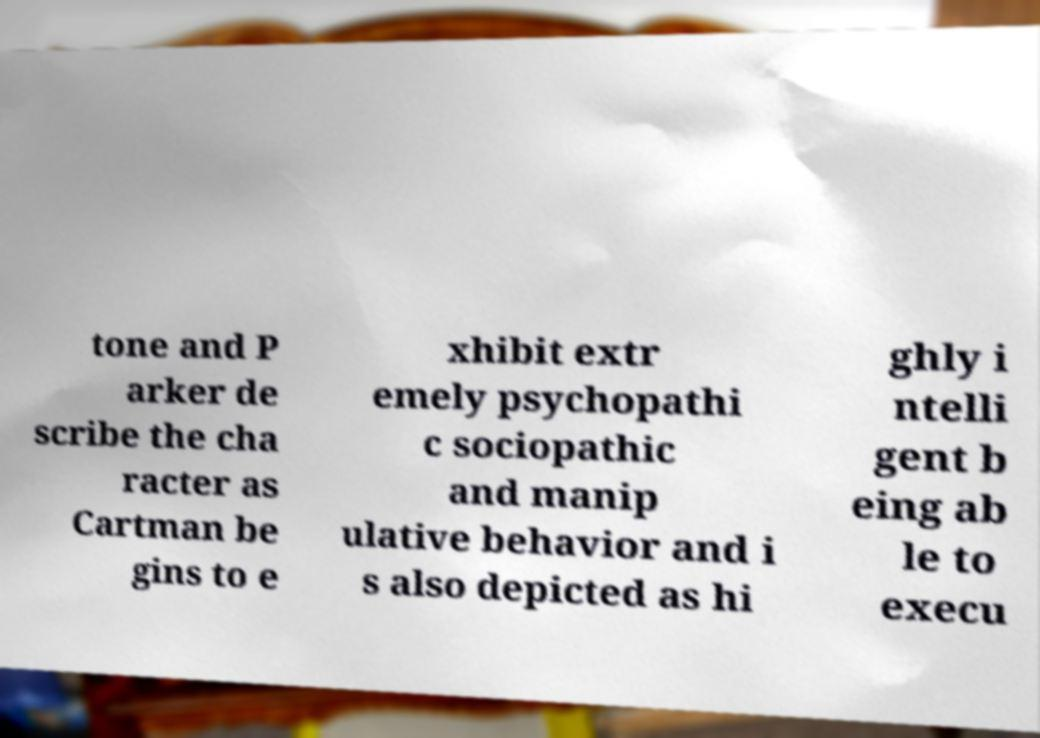For documentation purposes, I need the text within this image transcribed. Could you provide that? tone and P arker de scribe the cha racter as Cartman be gins to e xhibit extr emely psychopathi c sociopathic and manip ulative behavior and i s also depicted as hi ghly i ntelli gent b eing ab le to execu 